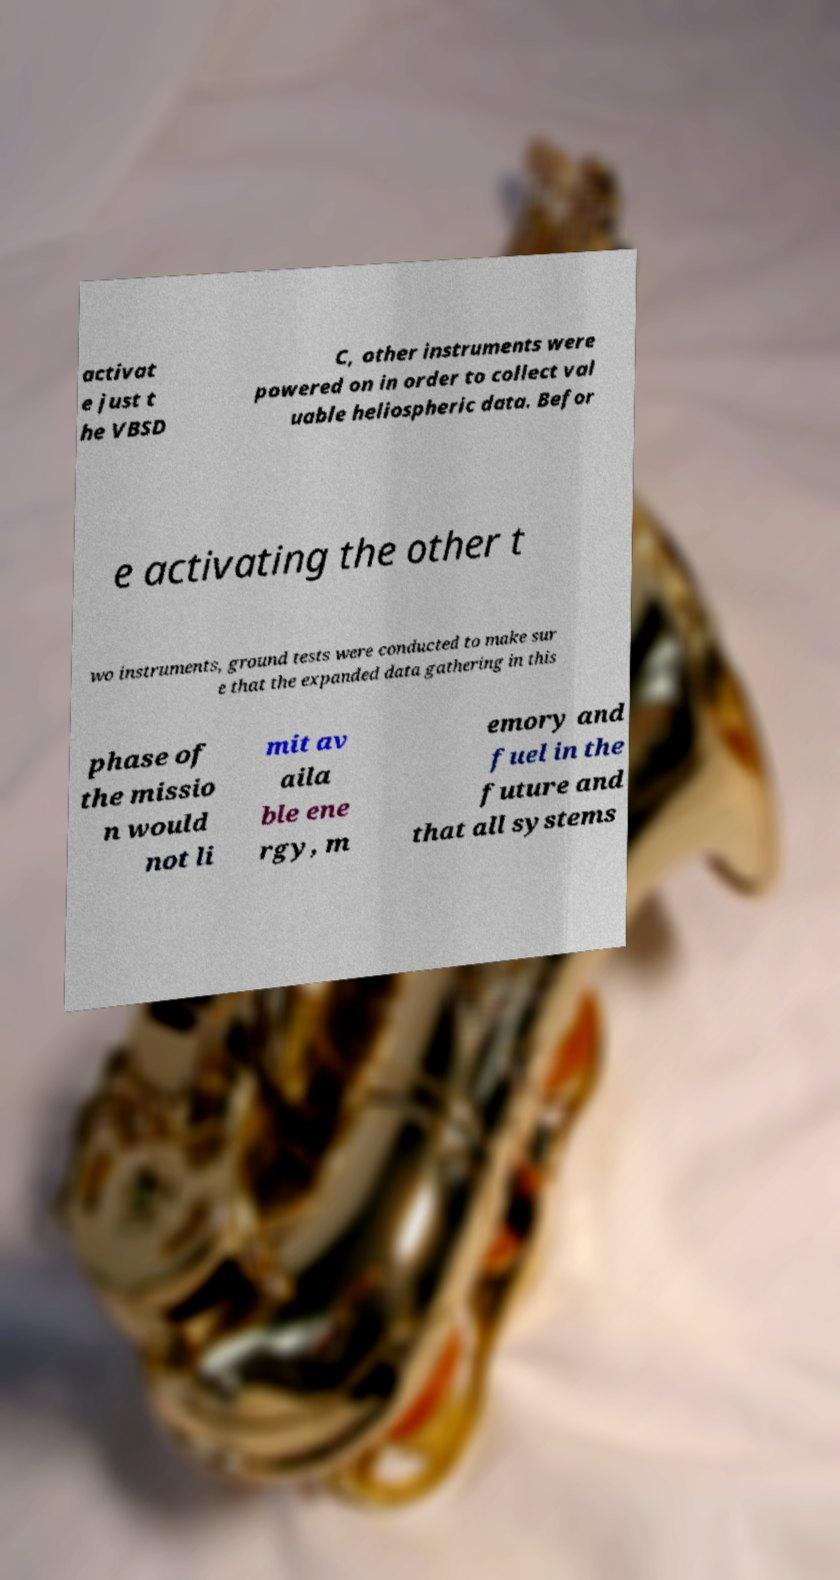There's text embedded in this image that I need extracted. Can you transcribe it verbatim? activat e just t he VBSD C, other instruments were powered on in order to collect val uable heliospheric data. Befor e activating the other t wo instruments, ground tests were conducted to make sur e that the expanded data gathering in this phase of the missio n would not li mit av aila ble ene rgy, m emory and fuel in the future and that all systems 